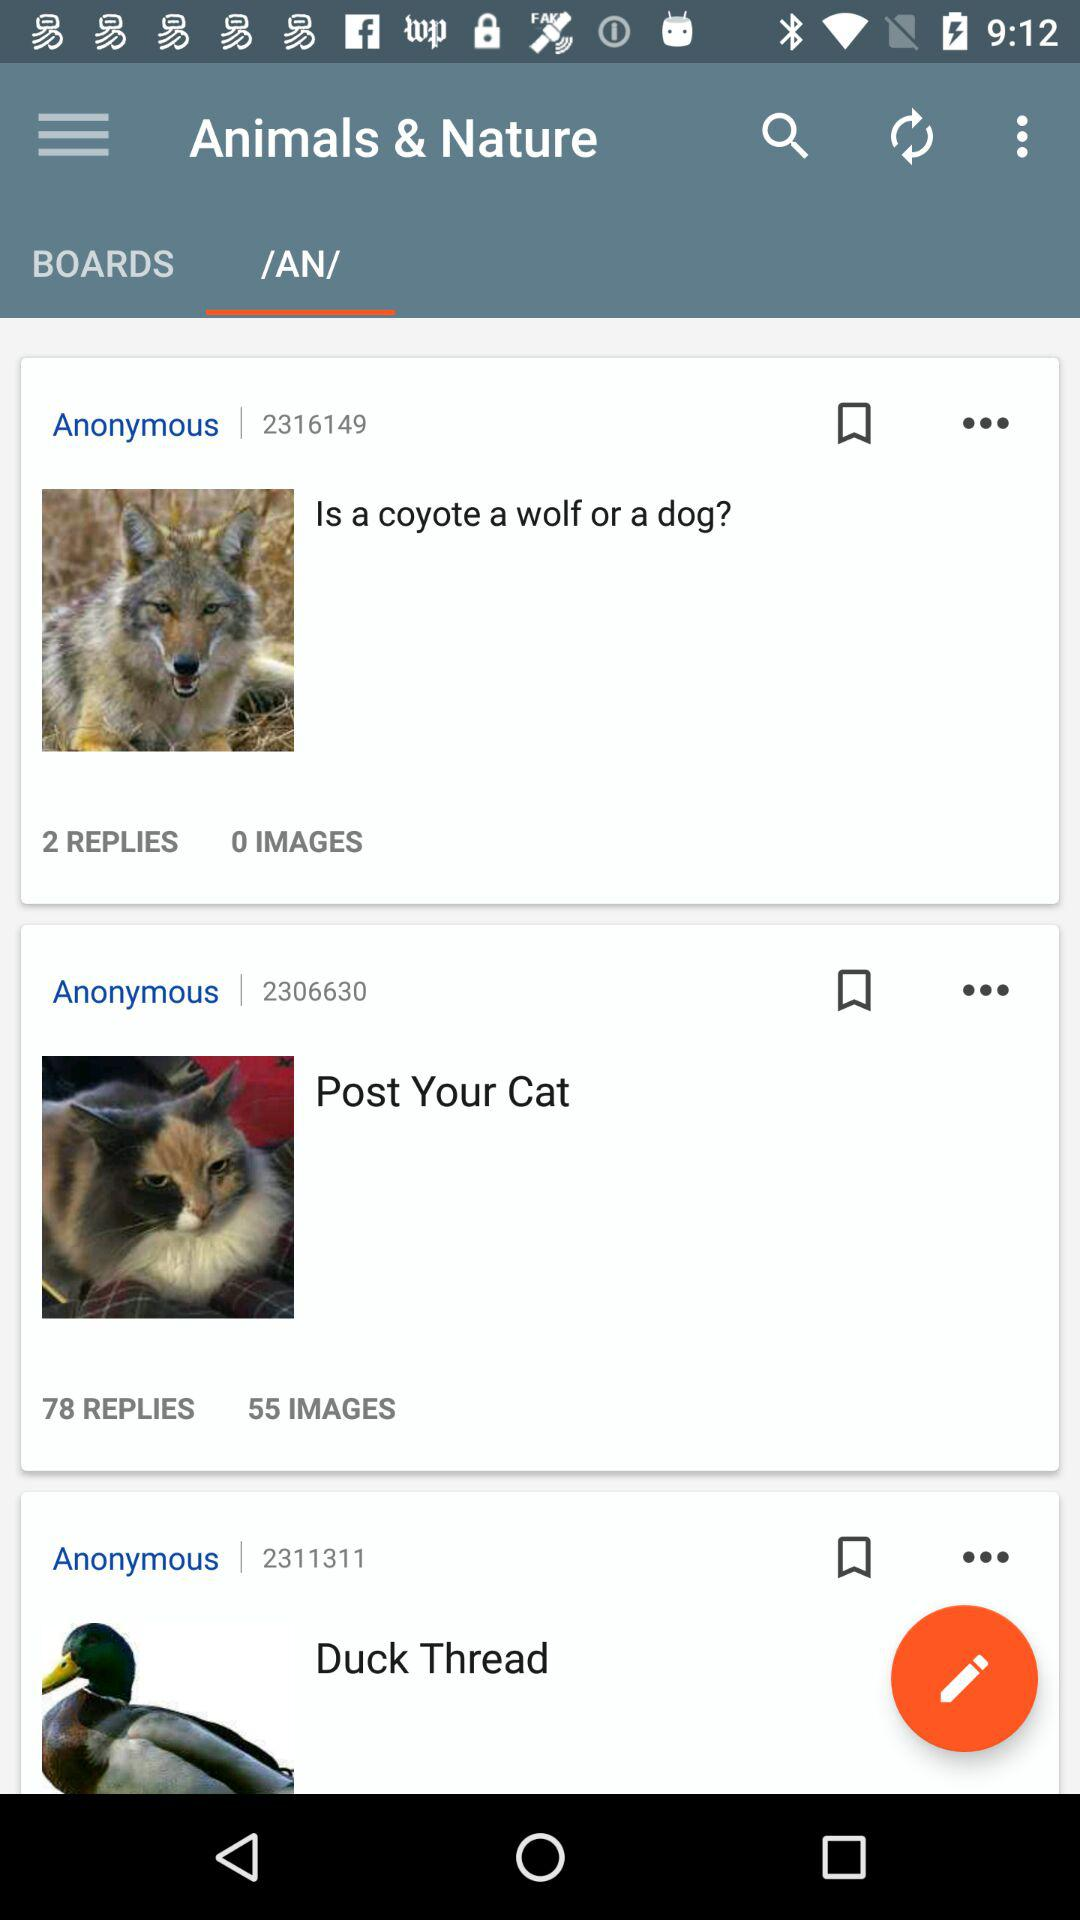How many images are there in "Is a coyote a wolf or a dog"? There are 0 images. 